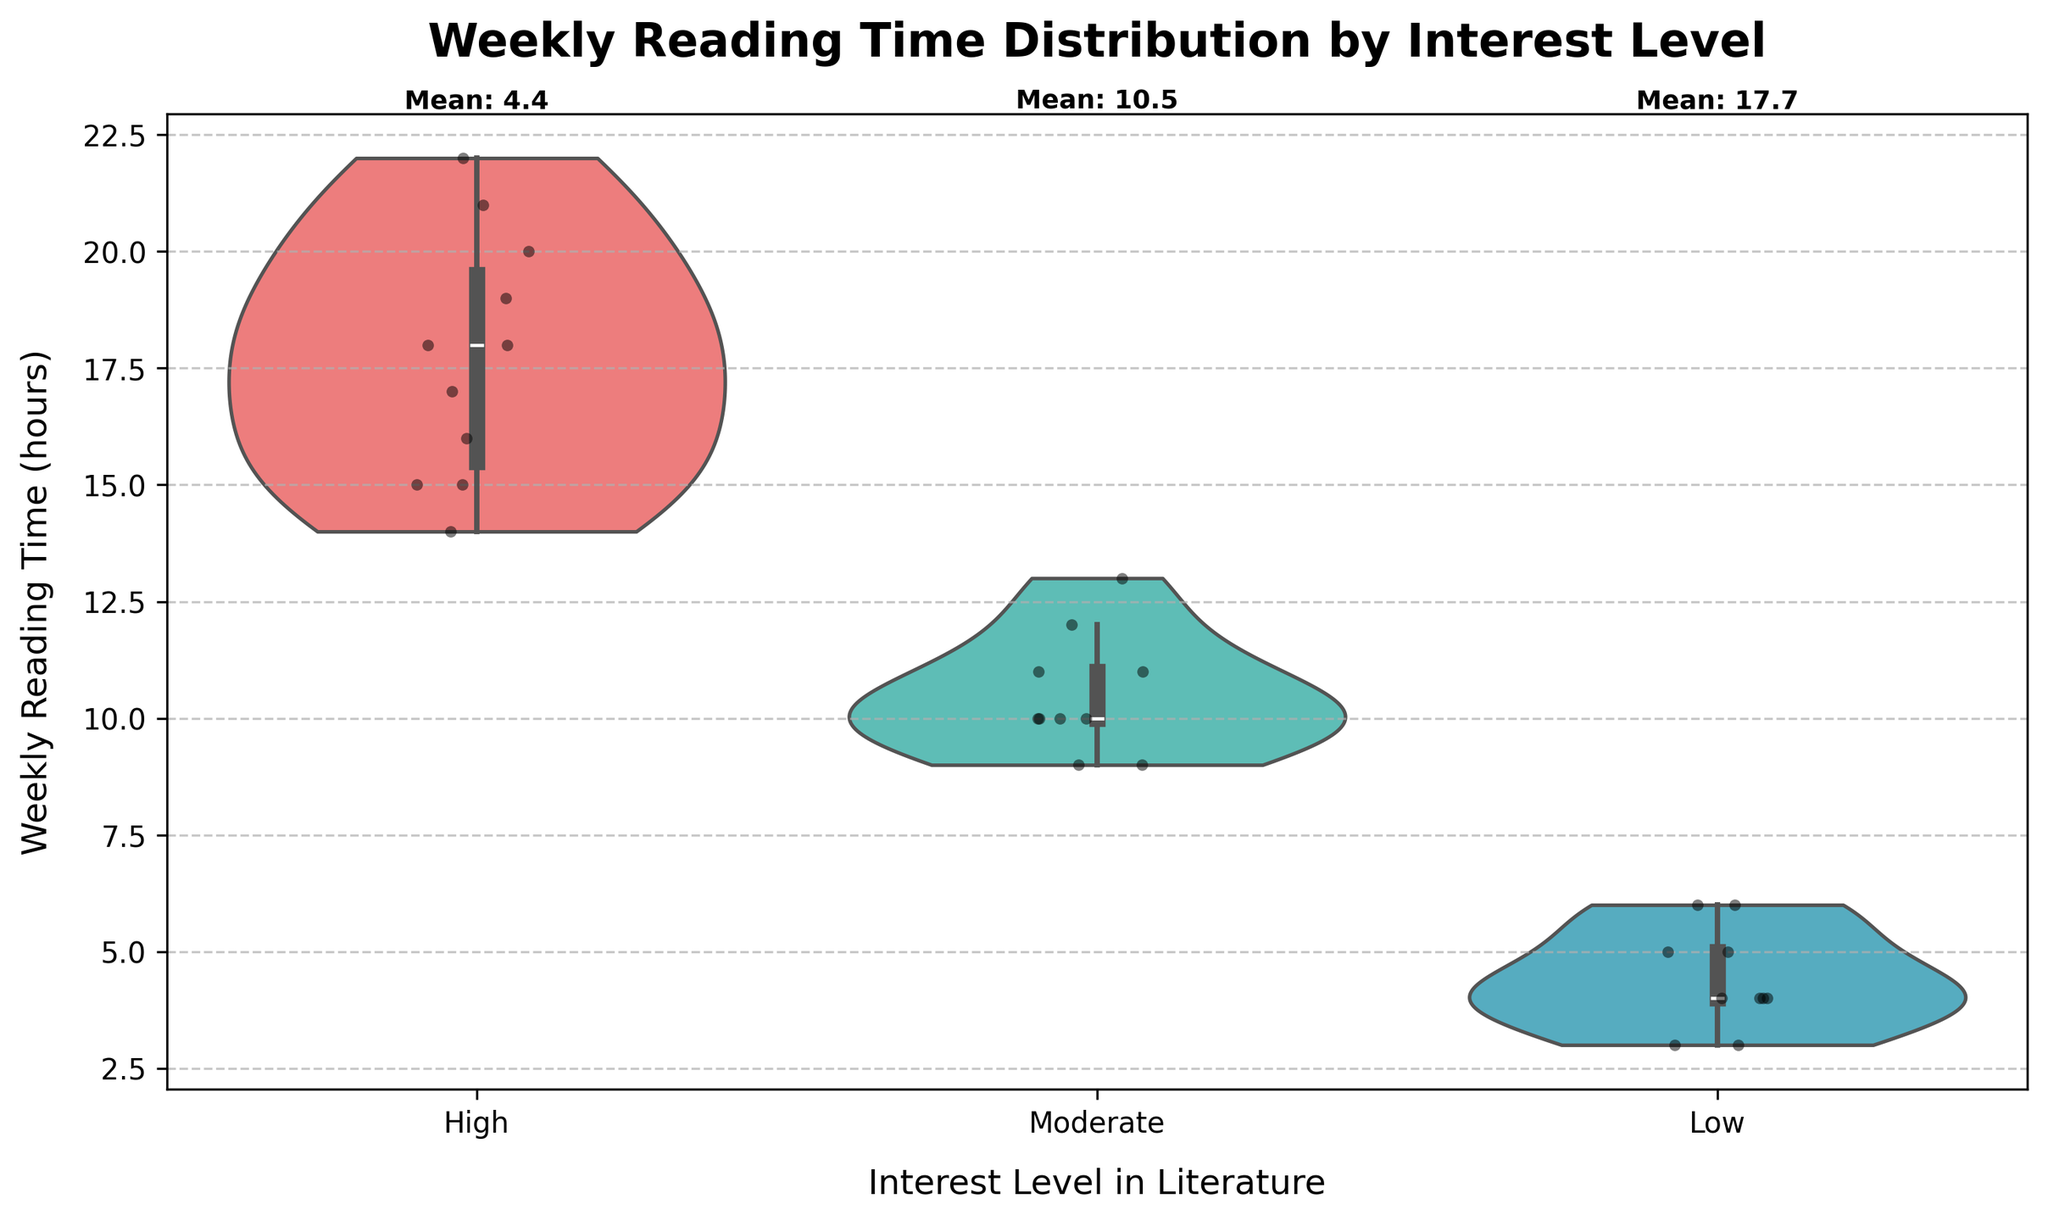What is the title of the figure? The title of the figure is located at the top and it reads "Weekly Reading Time Distribution by Interest Level".
Answer: Weekly Reading Time Distribution by Interest Level What are the categories on the x-axis? The x-axis categories represent different interest levels in literature and they are "Low", "Moderate", and "High".
Answer: Low, Moderate, High Which interest level shows the widest distribution of weekly reading time? By examining the width and spread of the violin plots, the "High" interest level has the widest distribution of weekly reading time.
Answer: High What is the mean weekly reading time for the "Moderate" interest level? The mean value for "Moderate" interest level is clearly labeled above the "Moderate" category as 10.5.
Answer: 10.5 Which interest level has the highest mean weekly reading time? By comparing the mean values labeled above each category, the "High" interest level has the highest mean reading time.
Answer: High Do any of the interest levels have their lowest reading time above 5 hours per week? Examining the lower bound of each violin plot, "Low" and "Moderate" categories include values below 5 hours, but "High" category does not. The minimum reading time for "High" is above 5 hours.
Answer: High Which interest level includes the lowest weekly reading time and what is that value? The "Low" interest level shows the lowest reading time. By inspecting the "Low" category on the violin plot, we can see the minimum value is 3 hours.
Answer: Low, 3 hours Compare the median weekly reading times between "Low" and "High" interest levels. Which one is higher and by approximately how much? The violin plots for "Low" and "High" interest levels show their medians as horizontal lines within the plot. The median for "Low" is around 4 hours, and for "High" it's around 18 hours. Thus, the "High" median is higher by approximately 14 hours.
Answer: High, by approximately 14 hours Is the distribution symmetric for any of the interest levels? The "High" interest level's violin plot appears more symmetric around its central median line, while "Low" and "Moderate" show more skewed distributions.
Answer: High Considering the shapes of the violin plots, which interest level appears to have the most consistent weekly reading time? The "Moderate" interest level has the narrowest and least variable shape, indicating more consistent weekly reading times compared to the others.
Answer: Moderate 